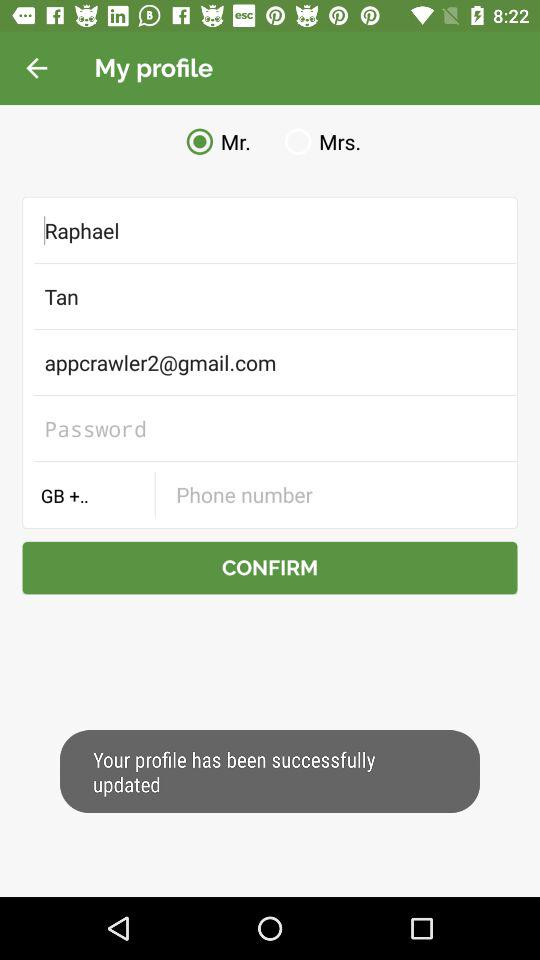What is the mail ID of a person? The mail ID of a person is appcrawler2@gmail.com. 